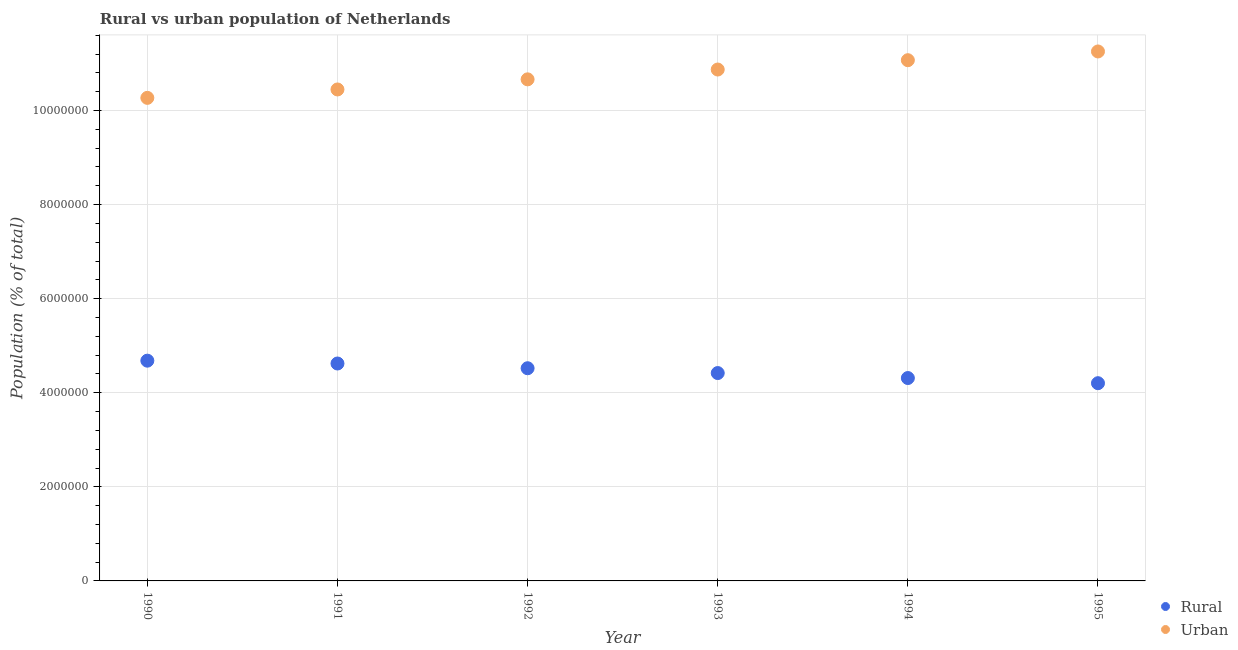How many different coloured dotlines are there?
Give a very brief answer. 2. Is the number of dotlines equal to the number of legend labels?
Offer a terse response. Yes. What is the urban population density in 1993?
Provide a succinct answer. 1.09e+07. Across all years, what is the maximum urban population density?
Your response must be concise. 1.13e+07. Across all years, what is the minimum urban population density?
Your response must be concise. 1.03e+07. In which year was the rural population density maximum?
Give a very brief answer. 1990. In which year was the rural population density minimum?
Offer a very short reply. 1995. What is the total urban population density in the graph?
Offer a very short reply. 6.46e+07. What is the difference between the urban population density in 1992 and that in 1994?
Provide a short and direct response. -4.07e+05. What is the difference between the urban population density in 1990 and the rural population density in 1995?
Ensure brevity in your answer.  6.07e+06. What is the average rural population density per year?
Offer a terse response. 4.46e+06. In the year 1992, what is the difference between the rural population density and urban population density?
Ensure brevity in your answer.  -6.14e+06. In how many years, is the urban population density greater than 400000 %?
Give a very brief answer. 6. What is the ratio of the rural population density in 1993 to that in 1994?
Your response must be concise. 1.02. Is the rural population density in 1990 less than that in 1992?
Provide a short and direct response. No. Is the difference between the rural population density in 1991 and 1994 greater than the difference between the urban population density in 1991 and 1994?
Provide a short and direct response. Yes. What is the difference between the highest and the second highest rural population density?
Ensure brevity in your answer.  6.02e+04. What is the difference between the highest and the lowest rural population density?
Your answer should be compact. 4.79e+05. In how many years, is the urban population density greater than the average urban population density taken over all years?
Offer a very short reply. 3. Is the sum of the rural population density in 1993 and 1994 greater than the maximum urban population density across all years?
Keep it short and to the point. No. How many years are there in the graph?
Provide a succinct answer. 6. Are the values on the major ticks of Y-axis written in scientific E-notation?
Make the answer very short. No. Does the graph contain any zero values?
Keep it short and to the point. No. Does the graph contain grids?
Provide a short and direct response. Yes. Where does the legend appear in the graph?
Provide a succinct answer. Bottom right. How many legend labels are there?
Offer a terse response. 2. What is the title of the graph?
Provide a succinct answer. Rural vs urban population of Netherlands. What is the label or title of the X-axis?
Keep it short and to the point. Year. What is the label or title of the Y-axis?
Your response must be concise. Population (% of total). What is the Population (% of total) of Rural in 1990?
Your answer should be very brief. 4.68e+06. What is the Population (% of total) of Urban in 1990?
Keep it short and to the point. 1.03e+07. What is the Population (% of total) of Rural in 1991?
Ensure brevity in your answer.  4.62e+06. What is the Population (% of total) of Urban in 1991?
Provide a succinct answer. 1.04e+07. What is the Population (% of total) in Rural in 1992?
Give a very brief answer. 4.52e+06. What is the Population (% of total) in Urban in 1992?
Offer a very short reply. 1.07e+07. What is the Population (% of total) in Rural in 1993?
Provide a succinct answer. 4.42e+06. What is the Population (% of total) of Urban in 1993?
Provide a succinct answer. 1.09e+07. What is the Population (% of total) in Rural in 1994?
Your answer should be very brief. 4.31e+06. What is the Population (% of total) of Urban in 1994?
Provide a succinct answer. 1.11e+07. What is the Population (% of total) in Rural in 1995?
Your response must be concise. 4.20e+06. What is the Population (% of total) in Urban in 1995?
Offer a very short reply. 1.13e+07. Across all years, what is the maximum Population (% of total) of Rural?
Offer a very short reply. 4.68e+06. Across all years, what is the maximum Population (% of total) in Urban?
Your answer should be compact. 1.13e+07. Across all years, what is the minimum Population (% of total) in Rural?
Your answer should be compact. 4.20e+06. Across all years, what is the minimum Population (% of total) of Urban?
Make the answer very short. 1.03e+07. What is the total Population (% of total) of Rural in the graph?
Provide a short and direct response. 2.68e+07. What is the total Population (% of total) of Urban in the graph?
Offer a very short reply. 6.46e+07. What is the difference between the Population (% of total) of Rural in 1990 and that in 1991?
Your answer should be very brief. 6.02e+04. What is the difference between the Population (% of total) in Urban in 1990 and that in 1991?
Give a very brief answer. -1.78e+05. What is the difference between the Population (% of total) in Rural in 1990 and that in 1992?
Give a very brief answer. 1.61e+05. What is the difference between the Population (% of total) of Urban in 1990 and that in 1992?
Provide a succinct answer. -3.93e+05. What is the difference between the Population (% of total) of Rural in 1990 and that in 1993?
Give a very brief answer. 2.63e+05. What is the difference between the Population (% of total) of Urban in 1990 and that in 1993?
Offer a very short reply. -6.02e+05. What is the difference between the Population (% of total) of Rural in 1990 and that in 1994?
Offer a very short reply. 3.69e+05. What is the difference between the Population (% of total) in Urban in 1990 and that in 1994?
Ensure brevity in your answer.  -8.01e+05. What is the difference between the Population (% of total) of Rural in 1990 and that in 1995?
Make the answer very short. 4.79e+05. What is the difference between the Population (% of total) of Urban in 1990 and that in 1995?
Ensure brevity in your answer.  -9.86e+05. What is the difference between the Population (% of total) in Rural in 1991 and that in 1992?
Give a very brief answer. 1.01e+05. What is the difference between the Population (% of total) of Urban in 1991 and that in 1992?
Offer a terse response. -2.15e+05. What is the difference between the Population (% of total) in Rural in 1991 and that in 1993?
Offer a terse response. 2.03e+05. What is the difference between the Population (% of total) in Urban in 1991 and that in 1993?
Make the answer very short. -4.24e+05. What is the difference between the Population (% of total) in Rural in 1991 and that in 1994?
Your answer should be compact. 3.09e+05. What is the difference between the Population (% of total) in Urban in 1991 and that in 1994?
Make the answer very short. -6.22e+05. What is the difference between the Population (% of total) of Rural in 1991 and that in 1995?
Your answer should be compact. 4.19e+05. What is the difference between the Population (% of total) in Urban in 1991 and that in 1995?
Offer a terse response. -8.08e+05. What is the difference between the Population (% of total) of Rural in 1992 and that in 1993?
Keep it short and to the point. 1.02e+05. What is the difference between the Population (% of total) in Urban in 1992 and that in 1993?
Offer a very short reply. -2.09e+05. What is the difference between the Population (% of total) in Rural in 1992 and that in 1994?
Provide a short and direct response. 2.08e+05. What is the difference between the Population (% of total) of Urban in 1992 and that in 1994?
Keep it short and to the point. -4.07e+05. What is the difference between the Population (% of total) in Rural in 1992 and that in 1995?
Make the answer very short. 3.18e+05. What is the difference between the Population (% of total) in Urban in 1992 and that in 1995?
Offer a very short reply. -5.93e+05. What is the difference between the Population (% of total) in Rural in 1993 and that in 1994?
Your answer should be compact. 1.06e+05. What is the difference between the Population (% of total) of Urban in 1993 and that in 1994?
Offer a terse response. -1.98e+05. What is the difference between the Population (% of total) of Rural in 1993 and that in 1995?
Provide a succinct answer. 2.15e+05. What is the difference between the Population (% of total) of Urban in 1993 and that in 1995?
Keep it short and to the point. -3.84e+05. What is the difference between the Population (% of total) of Rural in 1994 and that in 1995?
Your response must be concise. 1.10e+05. What is the difference between the Population (% of total) in Urban in 1994 and that in 1995?
Keep it short and to the point. -1.86e+05. What is the difference between the Population (% of total) in Rural in 1990 and the Population (% of total) in Urban in 1991?
Offer a terse response. -5.77e+06. What is the difference between the Population (% of total) in Rural in 1990 and the Population (% of total) in Urban in 1992?
Keep it short and to the point. -5.98e+06. What is the difference between the Population (% of total) in Rural in 1990 and the Population (% of total) in Urban in 1993?
Your response must be concise. -6.19e+06. What is the difference between the Population (% of total) in Rural in 1990 and the Population (% of total) in Urban in 1994?
Ensure brevity in your answer.  -6.39e+06. What is the difference between the Population (% of total) of Rural in 1990 and the Population (% of total) of Urban in 1995?
Your answer should be very brief. -6.57e+06. What is the difference between the Population (% of total) of Rural in 1991 and the Population (% of total) of Urban in 1992?
Provide a succinct answer. -6.04e+06. What is the difference between the Population (% of total) in Rural in 1991 and the Population (% of total) in Urban in 1993?
Offer a very short reply. -6.25e+06. What is the difference between the Population (% of total) of Rural in 1991 and the Population (% of total) of Urban in 1994?
Your answer should be very brief. -6.45e+06. What is the difference between the Population (% of total) in Rural in 1991 and the Population (% of total) in Urban in 1995?
Offer a very short reply. -6.63e+06. What is the difference between the Population (% of total) in Rural in 1992 and the Population (% of total) in Urban in 1993?
Your answer should be very brief. -6.35e+06. What is the difference between the Population (% of total) in Rural in 1992 and the Population (% of total) in Urban in 1994?
Keep it short and to the point. -6.55e+06. What is the difference between the Population (% of total) of Rural in 1992 and the Population (% of total) of Urban in 1995?
Your response must be concise. -6.73e+06. What is the difference between the Population (% of total) of Rural in 1993 and the Population (% of total) of Urban in 1994?
Your answer should be very brief. -6.65e+06. What is the difference between the Population (% of total) of Rural in 1993 and the Population (% of total) of Urban in 1995?
Ensure brevity in your answer.  -6.84e+06. What is the difference between the Population (% of total) in Rural in 1994 and the Population (% of total) in Urban in 1995?
Your response must be concise. -6.94e+06. What is the average Population (% of total) of Rural per year?
Your response must be concise. 4.46e+06. What is the average Population (% of total) of Urban per year?
Ensure brevity in your answer.  1.08e+07. In the year 1990, what is the difference between the Population (% of total) in Rural and Population (% of total) in Urban?
Ensure brevity in your answer.  -5.59e+06. In the year 1991, what is the difference between the Population (% of total) of Rural and Population (% of total) of Urban?
Provide a succinct answer. -5.83e+06. In the year 1992, what is the difference between the Population (% of total) of Rural and Population (% of total) of Urban?
Provide a succinct answer. -6.14e+06. In the year 1993, what is the difference between the Population (% of total) in Rural and Population (% of total) in Urban?
Give a very brief answer. -6.45e+06. In the year 1994, what is the difference between the Population (% of total) of Rural and Population (% of total) of Urban?
Provide a short and direct response. -6.76e+06. In the year 1995, what is the difference between the Population (% of total) of Rural and Population (% of total) of Urban?
Your answer should be very brief. -7.05e+06. What is the ratio of the Population (% of total) in Rural in 1990 to that in 1991?
Offer a terse response. 1.01. What is the ratio of the Population (% of total) in Urban in 1990 to that in 1991?
Your response must be concise. 0.98. What is the ratio of the Population (% of total) in Rural in 1990 to that in 1992?
Your answer should be very brief. 1.04. What is the ratio of the Population (% of total) in Urban in 1990 to that in 1992?
Give a very brief answer. 0.96. What is the ratio of the Population (% of total) in Rural in 1990 to that in 1993?
Offer a terse response. 1.06. What is the ratio of the Population (% of total) of Urban in 1990 to that in 1993?
Offer a very short reply. 0.94. What is the ratio of the Population (% of total) of Rural in 1990 to that in 1994?
Keep it short and to the point. 1.09. What is the ratio of the Population (% of total) in Urban in 1990 to that in 1994?
Offer a terse response. 0.93. What is the ratio of the Population (% of total) of Rural in 1990 to that in 1995?
Make the answer very short. 1.11. What is the ratio of the Population (% of total) of Urban in 1990 to that in 1995?
Give a very brief answer. 0.91. What is the ratio of the Population (% of total) in Rural in 1991 to that in 1992?
Provide a short and direct response. 1.02. What is the ratio of the Population (% of total) in Urban in 1991 to that in 1992?
Make the answer very short. 0.98. What is the ratio of the Population (% of total) of Rural in 1991 to that in 1993?
Your response must be concise. 1.05. What is the ratio of the Population (% of total) in Urban in 1991 to that in 1993?
Offer a terse response. 0.96. What is the ratio of the Population (% of total) of Rural in 1991 to that in 1994?
Your answer should be very brief. 1.07. What is the ratio of the Population (% of total) of Urban in 1991 to that in 1994?
Your answer should be compact. 0.94. What is the ratio of the Population (% of total) in Rural in 1991 to that in 1995?
Provide a succinct answer. 1.1. What is the ratio of the Population (% of total) in Urban in 1991 to that in 1995?
Make the answer very short. 0.93. What is the ratio of the Population (% of total) in Rural in 1992 to that in 1993?
Offer a very short reply. 1.02. What is the ratio of the Population (% of total) in Urban in 1992 to that in 1993?
Give a very brief answer. 0.98. What is the ratio of the Population (% of total) in Rural in 1992 to that in 1994?
Offer a terse response. 1.05. What is the ratio of the Population (% of total) in Urban in 1992 to that in 1994?
Provide a succinct answer. 0.96. What is the ratio of the Population (% of total) of Rural in 1992 to that in 1995?
Your answer should be compact. 1.08. What is the ratio of the Population (% of total) of Urban in 1992 to that in 1995?
Provide a succinct answer. 0.95. What is the ratio of the Population (% of total) in Rural in 1993 to that in 1994?
Your answer should be compact. 1.02. What is the ratio of the Population (% of total) in Urban in 1993 to that in 1994?
Give a very brief answer. 0.98. What is the ratio of the Population (% of total) of Rural in 1993 to that in 1995?
Your response must be concise. 1.05. What is the ratio of the Population (% of total) in Urban in 1993 to that in 1995?
Give a very brief answer. 0.97. What is the ratio of the Population (% of total) in Rural in 1994 to that in 1995?
Your answer should be very brief. 1.03. What is the ratio of the Population (% of total) in Urban in 1994 to that in 1995?
Give a very brief answer. 0.98. What is the difference between the highest and the second highest Population (% of total) of Rural?
Keep it short and to the point. 6.02e+04. What is the difference between the highest and the second highest Population (% of total) of Urban?
Give a very brief answer. 1.86e+05. What is the difference between the highest and the lowest Population (% of total) of Rural?
Make the answer very short. 4.79e+05. What is the difference between the highest and the lowest Population (% of total) in Urban?
Your answer should be compact. 9.86e+05. 